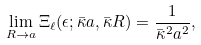<formula> <loc_0><loc_0><loc_500><loc_500>\lim _ { R \rightarrow a } \Xi _ { \ell } ( \epsilon ; \bar { \kappa } a , \bar { \kappa } R ) = \frac { 1 } { \bar { \kappa } ^ { 2 } a ^ { 2 } } ,</formula> 